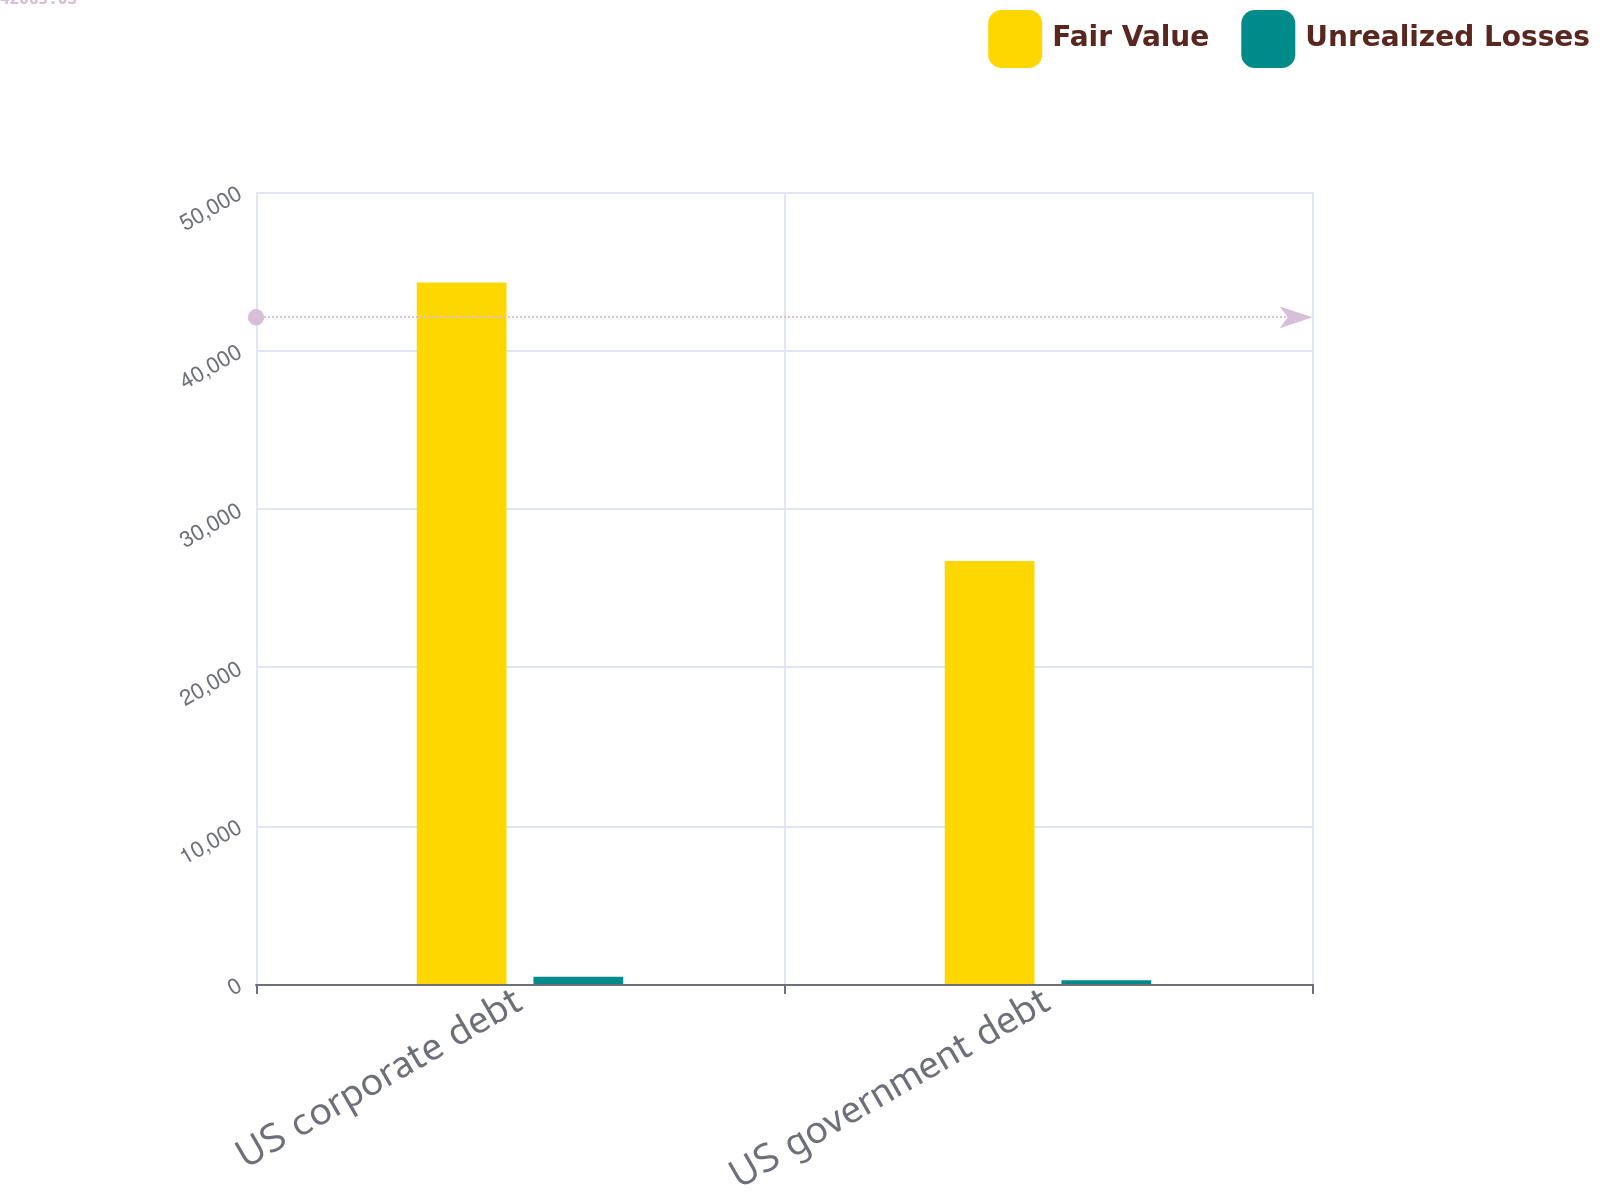<chart> <loc_0><loc_0><loc_500><loc_500><stacked_bar_chart><ecel><fcel>US corporate debt<fcel>US government debt<nl><fcel>Fair Value<fcel>44291<fcel>26703<nl><fcel>Unrealized Losses<fcel>463<fcel>243<nl></chart> 